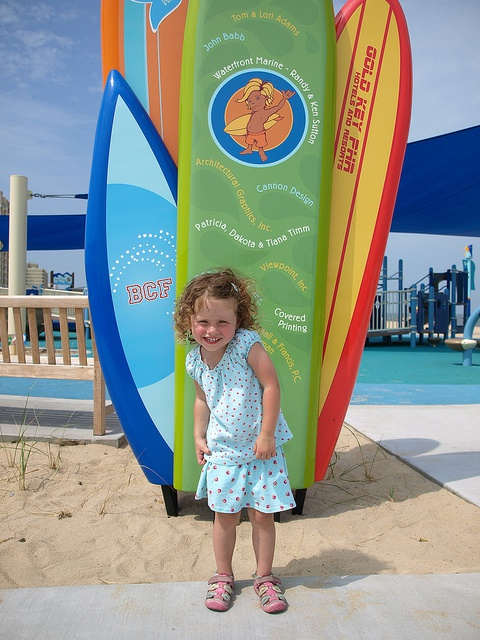Describe the objects in this image and their specific colors. I can see surfboard in gray, green, and olive tones, surfboard in gray, lightblue, and blue tones, surfboard in gray, tan, brown, and olive tones, people in gray, lightblue, and darkgray tones, and bench in gray, tan, and darkgray tones in this image. 